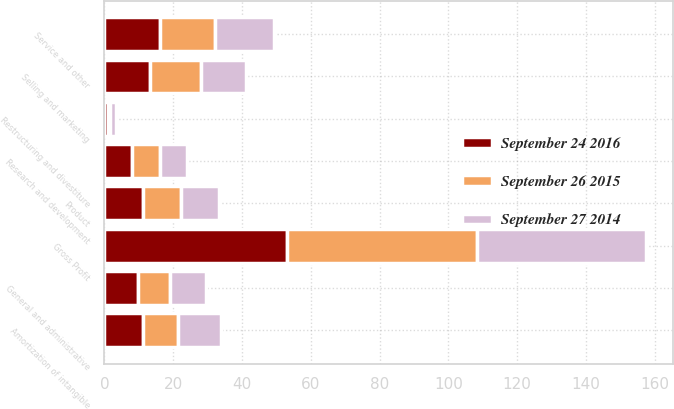Convert chart to OTSL. <chart><loc_0><loc_0><loc_500><loc_500><stacked_bar_chart><ecel><fcel>Product<fcel>Service and other<fcel>Amortization of intangible<fcel>Gross Profit<fcel>Research and development<fcel>Selling and marketing<fcel>General and administrative<fcel>Restructuring and divestiture<nl><fcel>September 26 2015<fcel>11.1<fcel>16<fcel>10.4<fcel>55.2<fcel>8.2<fcel>14.7<fcel>9.4<fcel>0.4<nl><fcel>September 24 2016<fcel>11.1<fcel>16.1<fcel>11.1<fcel>53<fcel>7.9<fcel>13.4<fcel>9.7<fcel>1.1<nl><fcel>September 27 2014<fcel>11.1<fcel>17.2<fcel>12.4<fcel>49.2<fcel>8<fcel>13.1<fcel>10.3<fcel>2<nl></chart> 